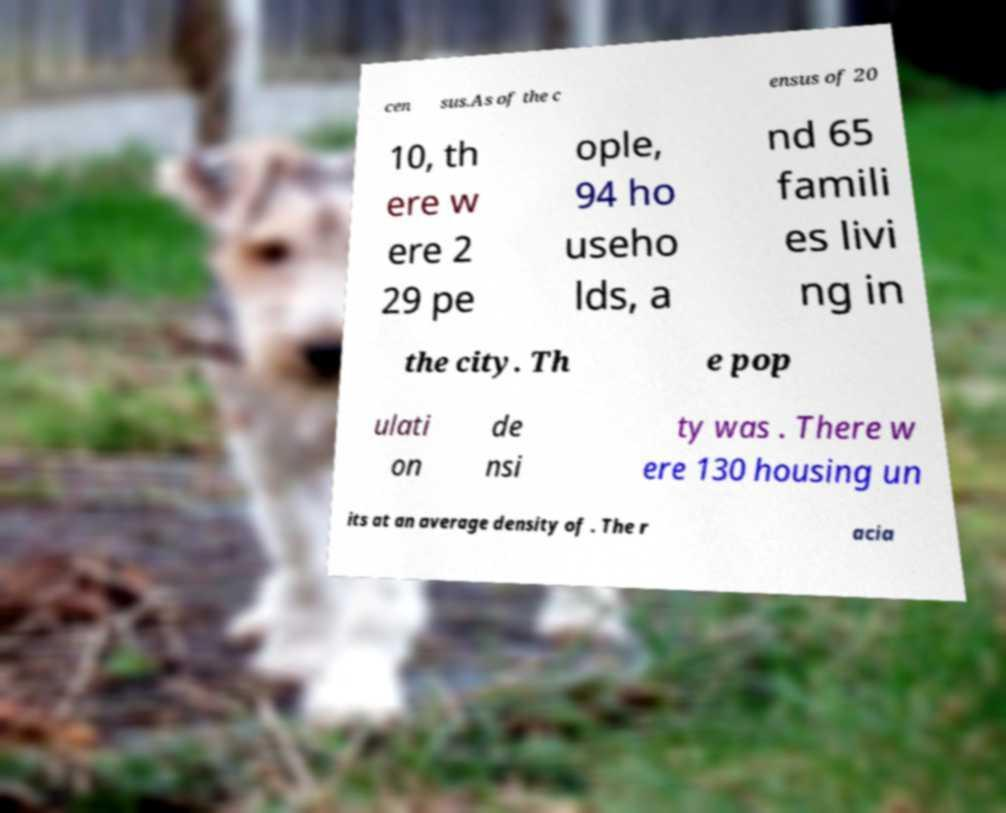Can you read and provide the text displayed in the image?This photo seems to have some interesting text. Can you extract and type it out for me? cen sus.As of the c ensus of 20 10, th ere w ere 2 29 pe ople, 94 ho useho lds, a nd 65 famili es livi ng in the city. Th e pop ulati on de nsi ty was . There w ere 130 housing un its at an average density of . The r acia 